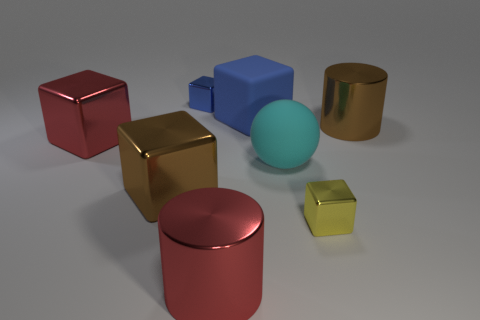Subtract all big blocks. How many blocks are left? 2 Add 1 brown metal balls. How many objects exist? 9 Subtract all yellow blocks. How many blocks are left? 4 Subtract 1 cyan balls. How many objects are left? 7 Subtract all cylinders. How many objects are left? 6 Subtract 1 spheres. How many spheres are left? 0 Subtract all yellow spheres. Subtract all cyan blocks. How many spheres are left? 1 Subtract all yellow cubes. How many cyan cylinders are left? 0 Subtract all big blue objects. Subtract all big cubes. How many objects are left? 4 Add 8 red cylinders. How many red cylinders are left? 9 